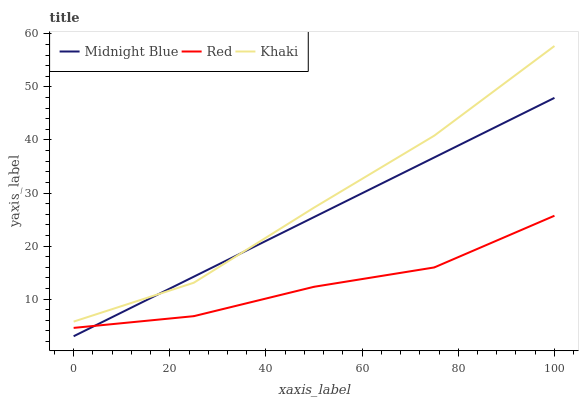Does Red have the minimum area under the curve?
Answer yes or no. Yes. Does Khaki have the maximum area under the curve?
Answer yes or no. Yes. Does Midnight Blue have the minimum area under the curve?
Answer yes or no. No. Does Midnight Blue have the maximum area under the curve?
Answer yes or no. No. Is Midnight Blue the smoothest?
Answer yes or no. Yes. Is Red the roughest?
Answer yes or no. Yes. Is Red the smoothest?
Answer yes or no. No. Is Midnight Blue the roughest?
Answer yes or no. No. Does Midnight Blue have the lowest value?
Answer yes or no. Yes. Does Red have the lowest value?
Answer yes or no. No. Does Khaki have the highest value?
Answer yes or no. Yes. Does Midnight Blue have the highest value?
Answer yes or no. No. Is Red less than Khaki?
Answer yes or no. Yes. Is Khaki greater than Red?
Answer yes or no. Yes. Does Red intersect Midnight Blue?
Answer yes or no. Yes. Is Red less than Midnight Blue?
Answer yes or no. No. Is Red greater than Midnight Blue?
Answer yes or no. No. Does Red intersect Khaki?
Answer yes or no. No. 